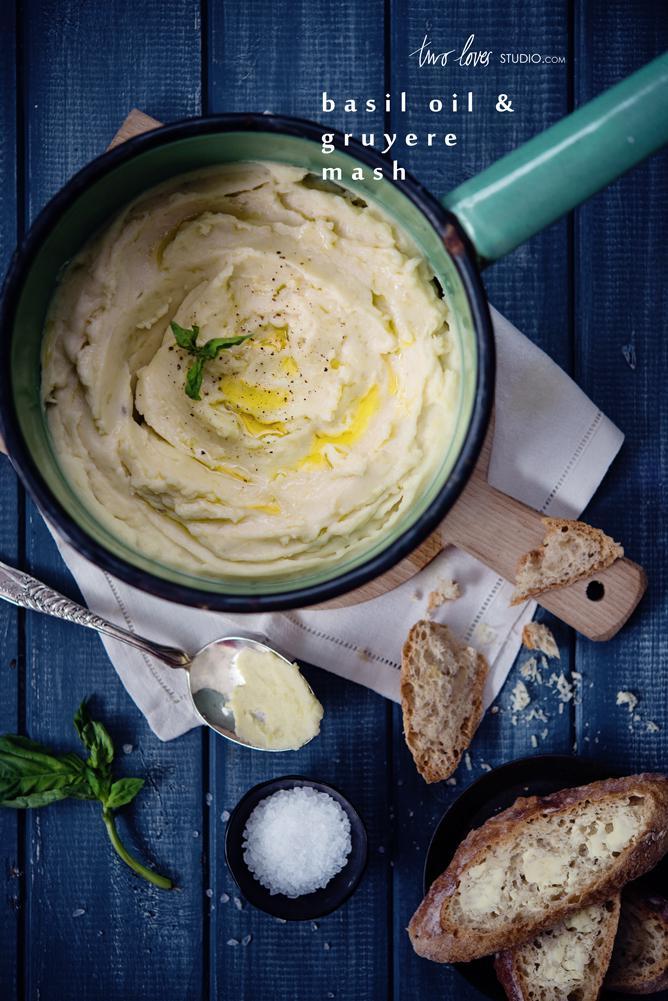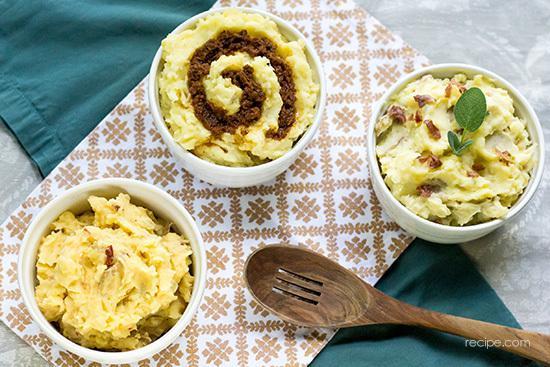The first image is the image on the left, the second image is the image on the right. Given the left and right images, does the statement "The mashed potatoes on the right have a spoon handle visibly sticking out of them" hold true? Answer yes or no. No. 